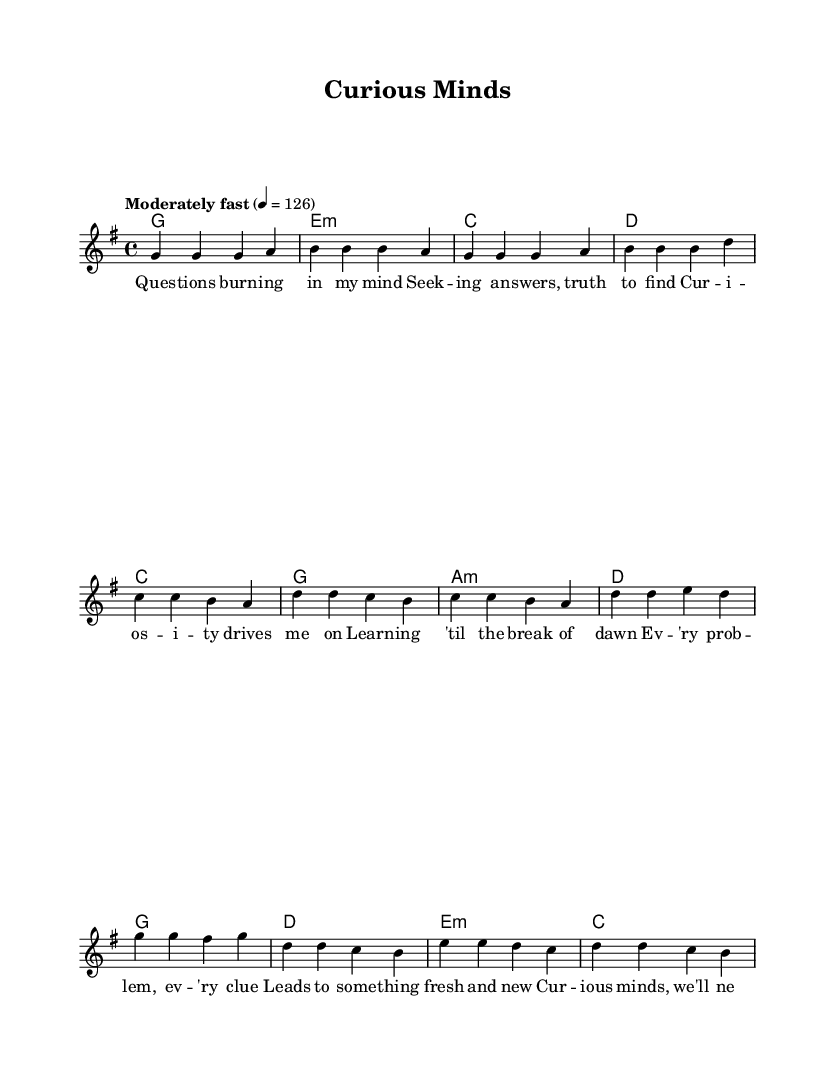What is the key signature of this music? The key signature is G major, which has one sharp (F#). This is identified by looking at the key signature symbol at the beginning of the staff.
Answer: G major What is the time signature of this music? The time signature is 4/4, indicated at the beginning of the score, showing that there are four beats per measure and the quarter note gets one beat.
Answer: 4/4 What is the tempo marking for the piece? The tempo marking is "Moderately fast" at a quarter note equals 126 beats per minute. This is noted at the beginning of the score, indicating the speed of the piece.
Answer: Moderately fast How many measures are in the verse section? The verse consists of 4 measures, which can be counted from the notation provided for the verse melody. Each line of melody corresponds to one measure.
Answer: 4 What is the first note of the chorus? The first note of the chorus is G, which is seen as the first note in the melody notation corresponding to the chorus section.
Answer: G Which musical structure is used for the pre-chorus? The pre-chorus follows a repeating structure, as evidenced by its two phrases with similar melodic and harmonic progressions that are mirrored in the lyric layout.
Answer: Repeating structure What thematic concept is emphasized in the lyrics? The thematic concept emphasized in the lyrics is intellectual curiosity and the pursuit of knowledge, which is reflected in phrases such as "questions burning in my mind" and "knowledge is our guiding light".
Answer: Intellectual curiosity 